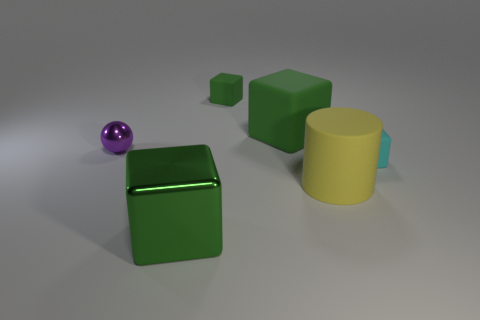Do the purple metal thing and the small cyan object have the same shape?
Ensure brevity in your answer.  No. There is a green rubber block that is right of the small matte object that is behind the tiny object to the right of the rubber cylinder; what is its size?
Your answer should be compact. Large. Is there a small green block behind the small thing that is behind the purple metal sphere?
Give a very brief answer. No. What number of tiny things are right of the large green object in front of the small rubber cube to the right of the big rubber cylinder?
Give a very brief answer. 2. There is a large thing that is in front of the small metallic ball and on the right side of the tiny green thing; what color is it?
Offer a terse response. Yellow. How many tiny rubber blocks are the same color as the cylinder?
Offer a very short reply. 0. What number of cylinders are small purple objects or large rubber objects?
Keep it short and to the point. 1. What color is the matte block that is the same size as the yellow thing?
Provide a succinct answer. Green. Are there any large green cubes that are in front of the big yellow matte thing on the right side of the shiny object that is behind the large yellow matte thing?
Offer a terse response. Yes. The yellow matte cylinder is what size?
Your response must be concise. Large. 